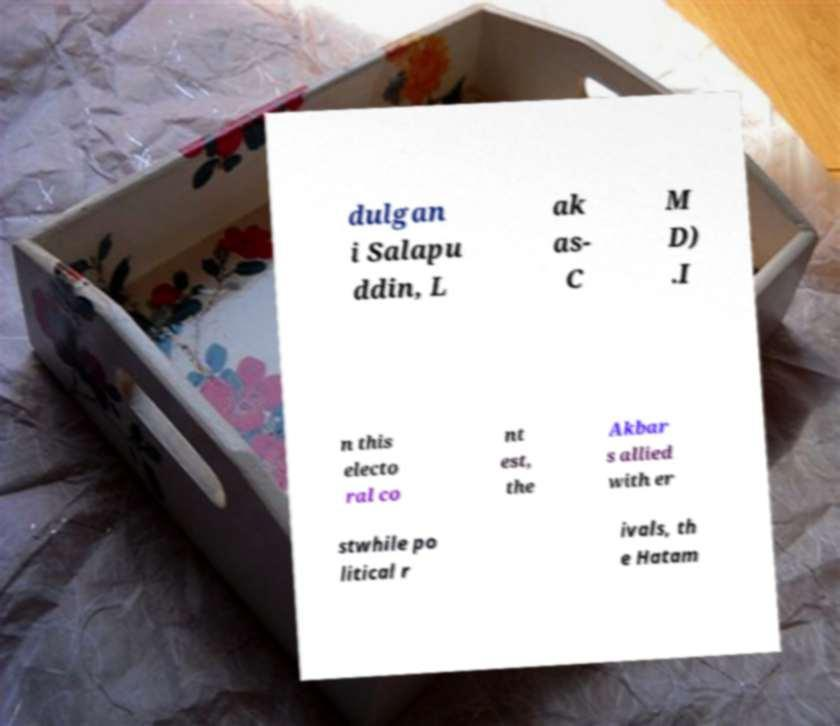Can you read and provide the text displayed in the image?This photo seems to have some interesting text. Can you extract and type it out for me? dulgan i Salapu ddin, L ak as- C M D) .I n this electo ral co nt est, the Akbar s allied with er stwhile po litical r ivals, th e Hatam 